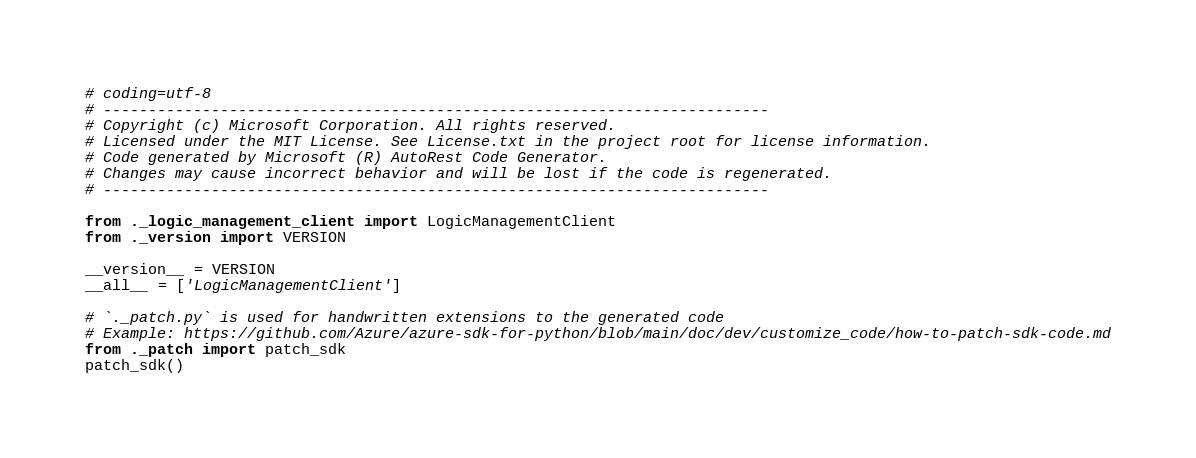Convert code to text. <code><loc_0><loc_0><loc_500><loc_500><_Python_># coding=utf-8
# --------------------------------------------------------------------------
# Copyright (c) Microsoft Corporation. All rights reserved.
# Licensed under the MIT License. See License.txt in the project root for license information.
# Code generated by Microsoft (R) AutoRest Code Generator.
# Changes may cause incorrect behavior and will be lost if the code is regenerated.
# --------------------------------------------------------------------------

from ._logic_management_client import LogicManagementClient
from ._version import VERSION

__version__ = VERSION
__all__ = ['LogicManagementClient']

# `._patch.py` is used for handwritten extensions to the generated code
# Example: https://github.com/Azure/azure-sdk-for-python/blob/main/doc/dev/customize_code/how-to-patch-sdk-code.md
from ._patch import patch_sdk
patch_sdk()
</code> 